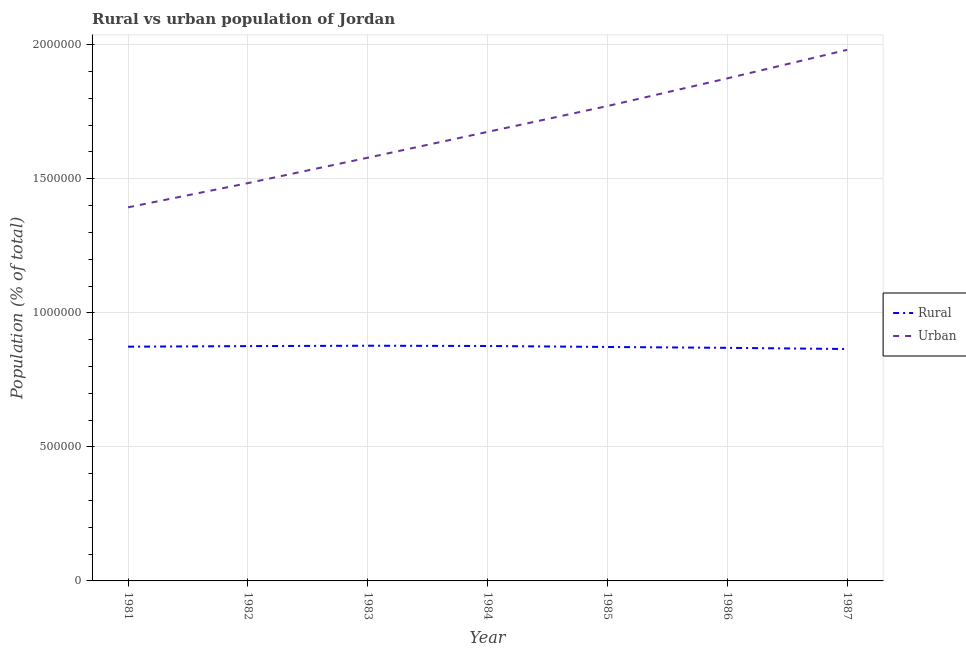How many different coloured lines are there?
Provide a short and direct response. 2. Is the number of lines equal to the number of legend labels?
Your answer should be compact. Yes. What is the urban population density in 1986?
Make the answer very short. 1.87e+06. Across all years, what is the maximum urban population density?
Make the answer very short. 1.98e+06. Across all years, what is the minimum urban population density?
Your answer should be very brief. 1.39e+06. In which year was the urban population density maximum?
Ensure brevity in your answer.  1987. In which year was the rural population density minimum?
Make the answer very short. 1987. What is the total rural population density in the graph?
Ensure brevity in your answer.  6.11e+06. What is the difference between the rural population density in 1984 and that in 1986?
Provide a short and direct response. 6885. What is the difference between the rural population density in 1983 and the urban population density in 1984?
Your answer should be very brief. -7.98e+05. What is the average urban population density per year?
Provide a short and direct response. 1.68e+06. In the year 1981, what is the difference between the rural population density and urban population density?
Your answer should be very brief. -5.20e+05. In how many years, is the rural population density greater than 800000 %?
Provide a short and direct response. 7. What is the ratio of the urban population density in 1983 to that in 1987?
Provide a short and direct response. 0.8. Is the urban population density in 1984 less than that in 1985?
Your answer should be compact. Yes. Is the difference between the urban population density in 1981 and 1987 greater than the difference between the rural population density in 1981 and 1987?
Your answer should be compact. No. What is the difference between the highest and the second highest rural population density?
Your answer should be very brief. 974. What is the difference between the highest and the lowest rural population density?
Provide a succinct answer. 1.23e+04. Is the sum of the urban population density in 1986 and 1987 greater than the maximum rural population density across all years?
Your response must be concise. Yes. Does the rural population density monotonically increase over the years?
Your answer should be very brief. No. Is the rural population density strictly greater than the urban population density over the years?
Provide a succinct answer. No. How many lines are there?
Your answer should be very brief. 2. How many years are there in the graph?
Keep it short and to the point. 7. Does the graph contain any zero values?
Your answer should be compact. No. Where does the legend appear in the graph?
Provide a short and direct response. Center right. How many legend labels are there?
Ensure brevity in your answer.  2. How are the legend labels stacked?
Offer a very short reply. Vertical. What is the title of the graph?
Make the answer very short. Rural vs urban population of Jordan. What is the label or title of the Y-axis?
Your answer should be very brief. Population (% of total). What is the Population (% of total) in Rural in 1981?
Offer a very short reply. 8.74e+05. What is the Population (% of total) of Urban in 1981?
Offer a terse response. 1.39e+06. What is the Population (% of total) of Rural in 1982?
Keep it short and to the point. 8.76e+05. What is the Population (% of total) in Urban in 1982?
Your answer should be very brief. 1.48e+06. What is the Population (% of total) of Rural in 1983?
Keep it short and to the point. 8.77e+05. What is the Population (% of total) in Urban in 1983?
Your response must be concise. 1.58e+06. What is the Population (% of total) in Rural in 1984?
Make the answer very short. 8.76e+05. What is the Population (% of total) of Urban in 1984?
Your answer should be very brief. 1.67e+06. What is the Population (% of total) of Rural in 1985?
Ensure brevity in your answer.  8.73e+05. What is the Population (% of total) of Urban in 1985?
Make the answer very short. 1.77e+06. What is the Population (% of total) in Rural in 1986?
Your response must be concise. 8.69e+05. What is the Population (% of total) in Urban in 1986?
Offer a very short reply. 1.87e+06. What is the Population (% of total) of Rural in 1987?
Give a very brief answer. 8.65e+05. What is the Population (% of total) of Urban in 1987?
Make the answer very short. 1.98e+06. Across all years, what is the maximum Population (% of total) of Rural?
Your answer should be very brief. 8.77e+05. Across all years, what is the maximum Population (% of total) of Urban?
Your answer should be very brief. 1.98e+06. Across all years, what is the minimum Population (% of total) of Rural?
Keep it short and to the point. 8.65e+05. Across all years, what is the minimum Population (% of total) of Urban?
Your response must be concise. 1.39e+06. What is the total Population (% of total) of Rural in the graph?
Keep it short and to the point. 6.11e+06. What is the total Population (% of total) in Urban in the graph?
Your answer should be compact. 1.18e+07. What is the difference between the Population (% of total) of Rural in 1981 and that in 1982?
Keep it short and to the point. -2188. What is the difference between the Population (% of total) in Urban in 1981 and that in 1982?
Ensure brevity in your answer.  -9.03e+04. What is the difference between the Population (% of total) in Rural in 1981 and that in 1983?
Ensure brevity in your answer.  -3589. What is the difference between the Population (% of total) in Urban in 1981 and that in 1983?
Keep it short and to the point. -1.85e+05. What is the difference between the Population (% of total) in Rural in 1981 and that in 1984?
Offer a terse response. -2615. What is the difference between the Population (% of total) in Urban in 1981 and that in 1984?
Keep it short and to the point. -2.81e+05. What is the difference between the Population (% of total) in Rural in 1981 and that in 1985?
Offer a very short reply. 1080. What is the difference between the Population (% of total) in Urban in 1981 and that in 1985?
Provide a succinct answer. -3.78e+05. What is the difference between the Population (% of total) in Rural in 1981 and that in 1986?
Make the answer very short. 4270. What is the difference between the Population (% of total) in Urban in 1981 and that in 1986?
Give a very brief answer. -4.81e+05. What is the difference between the Population (% of total) in Rural in 1981 and that in 1987?
Provide a succinct answer. 8693. What is the difference between the Population (% of total) of Urban in 1981 and that in 1987?
Your response must be concise. -5.87e+05. What is the difference between the Population (% of total) of Rural in 1982 and that in 1983?
Ensure brevity in your answer.  -1401. What is the difference between the Population (% of total) of Urban in 1982 and that in 1983?
Offer a very short reply. -9.47e+04. What is the difference between the Population (% of total) in Rural in 1982 and that in 1984?
Ensure brevity in your answer.  -427. What is the difference between the Population (% of total) of Urban in 1982 and that in 1984?
Keep it short and to the point. -1.91e+05. What is the difference between the Population (% of total) in Rural in 1982 and that in 1985?
Give a very brief answer. 3268. What is the difference between the Population (% of total) of Urban in 1982 and that in 1985?
Give a very brief answer. -2.88e+05. What is the difference between the Population (% of total) of Rural in 1982 and that in 1986?
Make the answer very short. 6458. What is the difference between the Population (% of total) of Urban in 1982 and that in 1986?
Your response must be concise. -3.91e+05. What is the difference between the Population (% of total) in Rural in 1982 and that in 1987?
Provide a succinct answer. 1.09e+04. What is the difference between the Population (% of total) of Urban in 1982 and that in 1987?
Make the answer very short. -4.97e+05. What is the difference between the Population (% of total) of Rural in 1983 and that in 1984?
Your answer should be very brief. 974. What is the difference between the Population (% of total) in Urban in 1983 and that in 1984?
Keep it short and to the point. -9.64e+04. What is the difference between the Population (% of total) of Rural in 1983 and that in 1985?
Your answer should be very brief. 4669. What is the difference between the Population (% of total) in Urban in 1983 and that in 1985?
Offer a terse response. -1.93e+05. What is the difference between the Population (% of total) of Rural in 1983 and that in 1986?
Your response must be concise. 7859. What is the difference between the Population (% of total) in Urban in 1983 and that in 1986?
Give a very brief answer. -2.96e+05. What is the difference between the Population (% of total) of Rural in 1983 and that in 1987?
Provide a succinct answer. 1.23e+04. What is the difference between the Population (% of total) of Urban in 1983 and that in 1987?
Ensure brevity in your answer.  -4.02e+05. What is the difference between the Population (% of total) in Rural in 1984 and that in 1985?
Your response must be concise. 3695. What is the difference between the Population (% of total) of Urban in 1984 and that in 1985?
Give a very brief answer. -9.64e+04. What is the difference between the Population (% of total) of Rural in 1984 and that in 1986?
Offer a terse response. 6885. What is the difference between the Population (% of total) of Urban in 1984 and that in 1986?
Your response must be concise. -2.00e+05. What is the difference between the Population (% of total) of Rural in 1984 and that in 1987?
Keep it short and to the point. 1.13e+04. What is the difference between the Population (% of total) of Urban in 1984 and that in 1987?
Provide a succinct answer. -3.06e+05. What is the difference between the Population (% of total) of Rural in 1985 and that in 1986?
Provide a short and direct response. 3190. What is the difference between the Population (% of total) in Urban in 1985 and that in 1986?
Keep it short and to the point. -1.03e+05. What is the difference between the Population (% of total) of Rural in 1985 and that in 1987?
Ensure brevity in your answer.  7613. What is the difference between the Population (% of total) of Urban in 1985 and that in 1987?
Provide a short and direct response. -2.10e+05. What is the difference between the Population (% of total) of Rural in 1986 and that in 1987?
Keep it short and to the point. 4423. What is the difference between the Population (% of total) of Urban in 1986 and that in 1987?
Give a very brief answer. -1.06e+05. What is the difference between the Population (% of total) of Rural in 1981 and the Population (% of total) of Urban in 1982?
Offer a very short reply. -6.10e+05. What is the difference between the Population (% of total) in Rural in 1981 and the Population (% of total) in Urban in 1983?
Your answer should be compact. -7.05e+05. What is the difference between the Population (% of total) of Rural in 1981 and the Population (% of total) of Urban in 1984?
Your answer should be compact. -8.01e+05. What is the difference between the Population (% of total) in Rural in 1981 and the Population (% of total) in Urban in 1985?
Your answer should be very brief. -8.98e+05. What is the difference between the Population (% of total) of Rural in 1981 and the Population (% of total) of Urban in 1986?
Keep it short and to the point. -1.00e+06. What is the difference between the Population (% of total) in Rural in 1981 and the Population (% of total) in Urban in 1987?
Your answer should be compact. -1.11e+06. What is the difference between the Population (% of total) in Rural in 1982 and the Population (% of total) in Urban in 1983?
Give a very brief answer. -7.03e+05. What is the difference between the Population (% of total) in Rural in 1982 and the Population (% of total) in Urban in 1984?
Provide a succinct answer. -7.99e+05. What is the difference between the Population (% of total) of Rural in 1982 and the Population (% of total) of Urban in 1985?
Your answer should be very brief. -8.95e+05. What is the difference between the Population (% of total) of Rural in 1982 and the Population (% of total) of Urban in 1986?
Ensure brevity in your answer.  -9.99e+05. What is the difference between the Population (% of total) of Rural in 1982 and the Population (% of total) of Urban in 1987?
Offer a very short reply. -1.11e+06. What is the difference between the Population (% of total) in Rural in 1983 and the Population (% of total) in Urban in 1984?
Your answer should be very brief. -7.98e+05. What is the difference between the Population (% of total) in Rural in 1983 and the Population (% of total) in Urban in 1985?
Provide a succinct answer. -8.94e+05. What is the difference between the Population (% of total) of Rural in 1983 and the Population (% of total) of Urban in 1986?
Offer a very short reply. -9.97e+05. What is the difference between the Population (% of total) of Rural in 1983 and the Population (% of total) of Urban in 1987?
Ensure brevity in your answer.  -1.10e+06. What is the difference between the Population (% of total) in Rural in 1984 and the Population (% of total) in Urban in 1985?
Keep it short and to the point. -8.95e+05. What is the difference between the Population (% of total) in Rural in 1984 and the Population (% of total) in Urban in 1986?
Provide a short and direct response. -9.98e+05. What is the difference between the Population (% of total) of Rural in 1984 and the Population (% of total) of Urban in 1987?
Make the answer very short. -1.10e+06. What is the difference between the Population (% of total) of Rural in 1985 and the Population (% of total) of Urban in 1986?
Offer a terse response. -1.00e+06. What is the difference between the Population (% of total) of Rural in 1985 and the Population (% of total) of Urban in 1987?
Offer a very short reply. -1.11e+06. What is the difference between the Population (% of total) in Rural in 1986 and the Population (% of total) in Urban in 1987?
Ensure brevity in your answer.  -1.11e+06. What is the average Population (% of total) of Rural per year?
Provide a succinct answer. 8.73e+05. What is the average Population (% of total) of Urban per year?
Keep it short and to the point. 1.68e+06. In the year 1981, what is the difference between the Population (% of total) in Rural and Population (% of total) in Urban?
Your response must be concise. -5.20e+05. In the year 1982, what is the difference between the Population (% of total) in Rural and Population (% of total) in Urban?
Offer a very short reply. -6.08e+05. In the year 1983, what is the difference between the Population (% of total) in Rural and Population (% of total) in Urban?
Your response must be concise. -7.01e+05. In the year 1984, what is the difference between the Population (% of total) in Rural and Population (% of total) in Urban?
Offer a very short reply. -7.99e+05. In the year 1985, what is the difference between the Population (% of total) in Rural and Population (% of total) in Urban?
Give a very brief answer. -8.99e+05. In the year 1986, what is the difference between the Population (% of total) in Rural and Population (% of total) in Urban?
Keep it short and to the point. -1.01e+06. In the year 1987, what is the difference between the Population (% of total) in Rural and Population (% of total) in Urban?
Ensure brevity in your answer.  -1.12e+06. What is the ratio of the Population (% of total) in Rural in 1981 to that in 1982?
Provide a short and direct response. 1. What is the ratio of the Population (% of total) in Urban in 1981 to that in 1982?
Your answer should be very brief. 0.94. What is the ratio of the Population (% of total) of Rural in 1981 to that in 1983?
Give a very brief answer. 1. What is the ratio of the Population (% of total) of Urban in 1981 to that in 1983?
Ensure brevity in your answer.  0.88. What is the ratio of the Population (% of total) of Urban in 1981 to that in 1984?
Your response must be concise. 0.83. What is the ratio of the Population (% of total) of Urban in 1981 to that in 1985?
Your answer should be compact. 0.79. What is the ratio of the Population (% of total) in Urban in 1981 to that in 1986?
Give a very brief answer. 0.74. What is the ratio of the Population (% of total) in Rural in 1981 to that in 1987?
Give a very brief answer. 1.01. What is the ratio of the Population (% of total) in Urban in 1981 to that in 1987?
Offer a terse response. 0.7. What is the ratio of the Population (% of total) of Urban in 1982 to that in 1984?
Ensure brevity in your answer.  0.89. What is the ratio of the Population (% of total) of Rural in 1982 to that in 1985?
Ensure brevity in your answer.  1. What is the ratio of the Population (% of total) of Urban in 1982 to that in 1985?
Your answer should be compact. 0.84. What is the ratio of the Population (% of total) in Rural in 1982 to that in 1986?
Offer a very short reply. 1.01. What is the ratio of the Population (% of total) in Urban in 1982 to that in 1986?
Your answer should be very brief. 0.79. What is the ratio of the Population (% of total) in Rural in 1982 to that in 1987?
Give a very brief answer. 1.01. What is the ratio of the Population (% of total) in Urban in 1982 to that in 1987?
Ensure brevity in your answer.  0.75. What is the ratio of the Population (% of total) of Rural in 1983 to that in 1984?
Provide a succinct answer. 1. What is the ratio of the Population (% of total) in Urban in 1983 to that in 1984?
Provide a short and direct response. 0.94. What is the ratio of the Population (% of total) in Rural in 1983 to that in 1985?
Make the answer very short. 1.01. What is the ratio of the Population (% of total) in Urban in 1983 to that in 1985?
Offer a very short reply. 0.89. What is the ratio of the Population (% of total) of Rural in 1983 to that in 1986?
Your answer should be very brief. 1.01. What is the ratio of the Population (% of total) in Urban in 1983 to that in 1986?
Provide a short and direct response. 0.84. What is the ratio of the Population (% of total) in Rural in 1983 to that in 1987?
Offer a very short reply. 1.01. What is the ratio of the Population (% of total) of Urban in 1983 to that in 1987?
Make the answer very short. 0.8. What is the ratio of the Population (% of total) of Urban in 1984 to that in 1985?
Provide a short and direct response. 0.95. What is the ratio of the Population (% of total) of Rural in 1984 to that in 1986?
Provide a short and direct response. 1.01. What is the ratio of the Population (% of total) of Urban in 1984 to that in 1986?
Your answer should be compact. 0.89. What is the ratio of the Population (% of total) of Rural in 1984 to that in 1987?
Your response must be concise. 1.01. What is the ratio of the Population (% of total) of Urban in 1984 to that in 1987?
Keep it short and to the point. 0.85. What is the ratio of the Population (% of total) of Rural in 1985 to that in 1986?
Ensure brevity in your answer.  1. What is the ratio of the Population (% of total) of Urban in 1985 to that in 1986?
Make the answer very short. 0.94. What is the ratio of the Population (% of total) in Rural in 1985 to that in 1987?
Give a very brief answer. 1.01. What is the ratio of the Population (% of total) in Urban in 1985 to that in 1987?
Give a very brief answer. 0.89. What is the ratio of the Population (% of total) in Urban in 1986 to that in 1987?
Keep it short and to the point. 0.95. What is the difference between the highest and the second highest Population (% of total) of Rural?
Your answer should be very brief. 974. What is the difference between the highest and the second highest Population (% of total) of Urban?
Your answer should be very brief. 1.06e+05. What is the difference between the highest and the lowest Population (% of total) in Rural?
Your response must be concise. 1.23e+04. What is the difference between the highest and the lowest Population (% of total) in Urban?
Provide a short and direct response. 5.87e+05. 